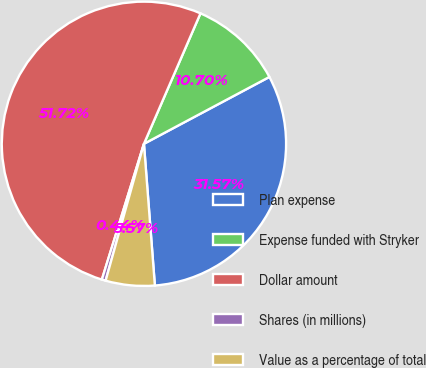<chart> <loc_0><loc_0><loc_500><loc_500><pie_chart><fcel>Plan expense<fcel>Expense funded with Stryker<fcel>Dollar amount<fcel>Shares (in millions)<fcel>Value as a percentage of total<nl><fcel>31.57%<fcel>10.7%<fcel>51.73%<fcel>0.44%<fcel>5.57%<nl></chart> 